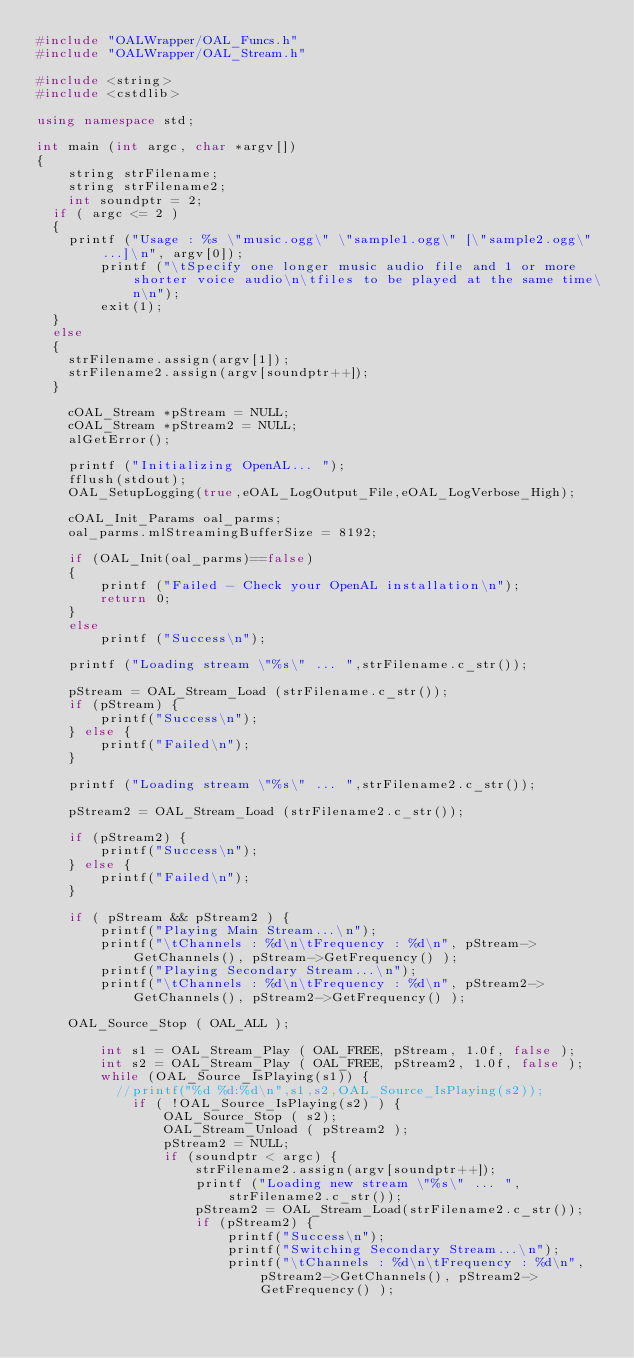<code> <loc_0><loc_0><loc_500><loc_500><_C++_>#include "OALWrapper/OAL_Funcs.h"
#include "OALWrapper/OAL_Stream.h"

#include <string>
#include <cstdlib>

using namespace std;

int main (int argc, char *argv[])
{
    string strFilename;
    string strFilename2;
    int soundptr = 2;
	if ( argc <= 2 )
	{
		printf ("Usage : %s \"music.ogg\" \"sample1.ogg\" [\"sample2.ogg\" ...]\n", argv[0]);
        printf ("\tSpecify one longer music audio file and 1 or more shorter voice audio\n\tfiles to be played at the same time\n\n");
        exit(1);
	}
	else
	{
		strFilename.assign(argv[1]);
		strFilename2.assign(argv[soundptr++]);
	}

    cOAL_Stream *pStream = NULL;
    cOAL_Stream *pStream2 = NULL;
    alGetError();

    printf ("Initializing OpenAL... ");
    fflush(stdout);
    OAL_SetupLogging(true,eOAL_LogOutput_File,eOAL_LogVerbose_High);
    
    cOAL_Init_Params oal_parms;
    oal_parms.mlStreamingBufferSize = 8192;

    if (OAL_Init(oal_parms)==false)
    {
        printf ("Failed - Check your OpenAL installation\n");
        return 0;
    }
    else
        printf ("Success\n");

    printf ("Loading stream \"%s\" ... ",strFilename.c_str());

    pStream = OAL_Stream_Load (strFilename.c_str());
    if (pStream) {
        printf("Success\n");
    } else {
        printf("Failed\n");
    }

    printf ("Loading stream \"%s\" ... ",strFilename2.c_str());

    pStream2 = OAL_Stream_Load (strFilename2.c_str());

    if (pStream2) {
        printf("Success\n");
    } else {
        printf("Failed\n");
    }

    if ( pStream && pStream2 ) {
        printf("Playing Main Stream...\n");
        printf("\tChannels : %d\n\tFrequency : %d\n", pStream->GetChannels(), pStream->GetFrequency() );
        printf("Playing Secondary Stream...\n");
        printf("\tChannels : %d\n\tFrequency : %d\n", pStream2->GetChannels(), pStream2->GetFrequency() );

		OAL_Source_Stop ( OAL_ALL );

        int s1 = OAL_Stream_Play ( OAL_FREE, pStream, 1.0f, false );
        int s2 = OAL_Stream_Play ( OAL_FREE, pStream2, 1.0f, false );
        while (OAL_Source_IsPlaying(s1)) {
        	//printf("%d %d:%d\n",s1,s2,OAL_Source_IsPlaying(s2));
            if ( !OAL_Source_IsPlaying(s2) ) {
                OAL_Source_Stop ( s2);
                OAL_Stream_Unload ( pStream2 );
                pStream2 = NULL;
                if (soundptr < argc) {
                    strFilename2.assign(argv[soundptr++]);
                    printf ("Loading new stream \"%s\" ... ",strFilename2.c_str());
                    pStream2 = OAL_Stream_Load(strFilename2.c_str());
                    if (pStream2) {
                        printf("Success\n");
                        printf("Switching Secondary Stream...\n");
                        printf("\tChannels : %d\n\tFrequency : %d\n", pStream2->GetChannels(), pStream2->GetFrequency() );</code> 